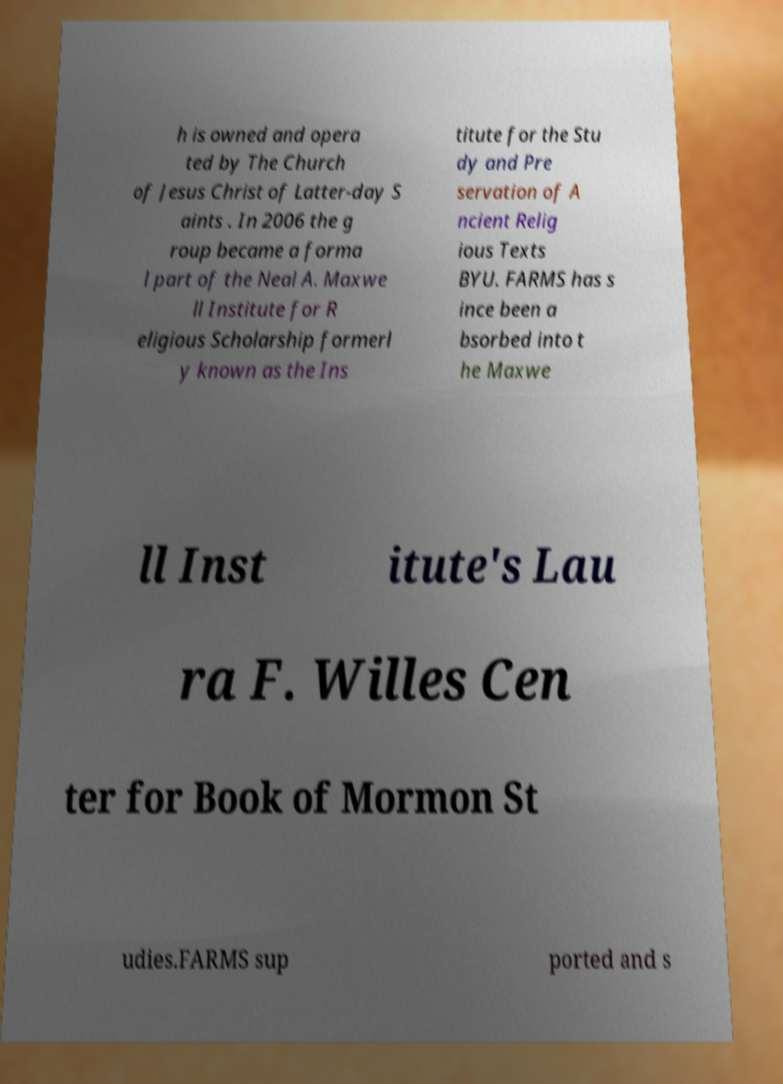Can you accurately transcribe the text from the provided image for me? h is owned and opera ted by The Church of Jesus Christ of Latter-day S aints . In 2006 the g roup became a forma l part of the Neal A. Maxwe ll Institute for R eligious Scholarship formerl y known as the Ins titute for the Stu dy and Pre servation of A ncient Relig ious Texts BYU. FARMS has s ince been a bsorbed into t he Maxwe ll Inst itute's Lau ra F. Willes Cen ter for Book of Mormon St udies.FARMS sup ported and s 